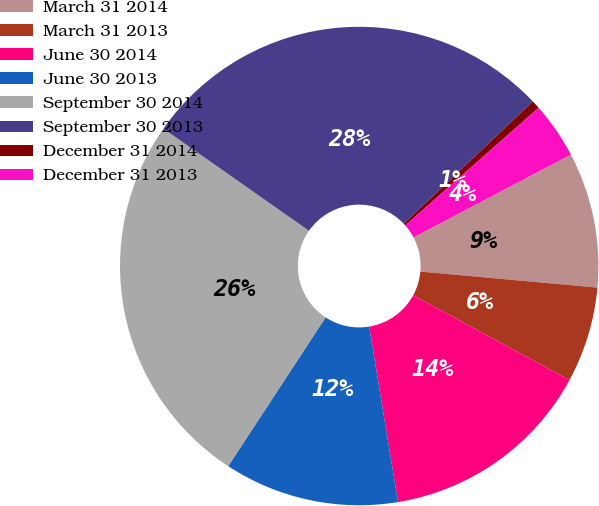Convert chart. <chart><loc_0><loc_0><loc_500><loc_500><pie_chart><fcel>March 31 2014<fcel>March 31 2013<fcel>June 30 2014<fcel>June 30 2013<fcel>September 30 2014<fcel>September 30 2013<fcel>December 31 2014<fcel>December 31 2013<nl><fcel>9.15%<fcel>6.47%<fcel>14.5%<fcel>11.82%<fcel>25.51%<fcel>28.19%<fcel>0.57%<fcel>3.79%<nl></chart> 